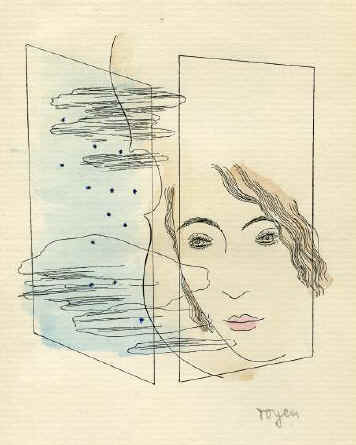What does this particular style of line drawing suggest about the emotions or personality of the subject? The minimalist style of line drawing used to depict the woman’s face suggests a form of raw emotional expression, where simplicity enhances focus on the subtle expressions and features. It could imply a restrained or introspective personality, or perhaps suggest a veneer of simplicity that masks a more turbulent emotional landscape, as hinted by the abstract elements surrounding the face. 